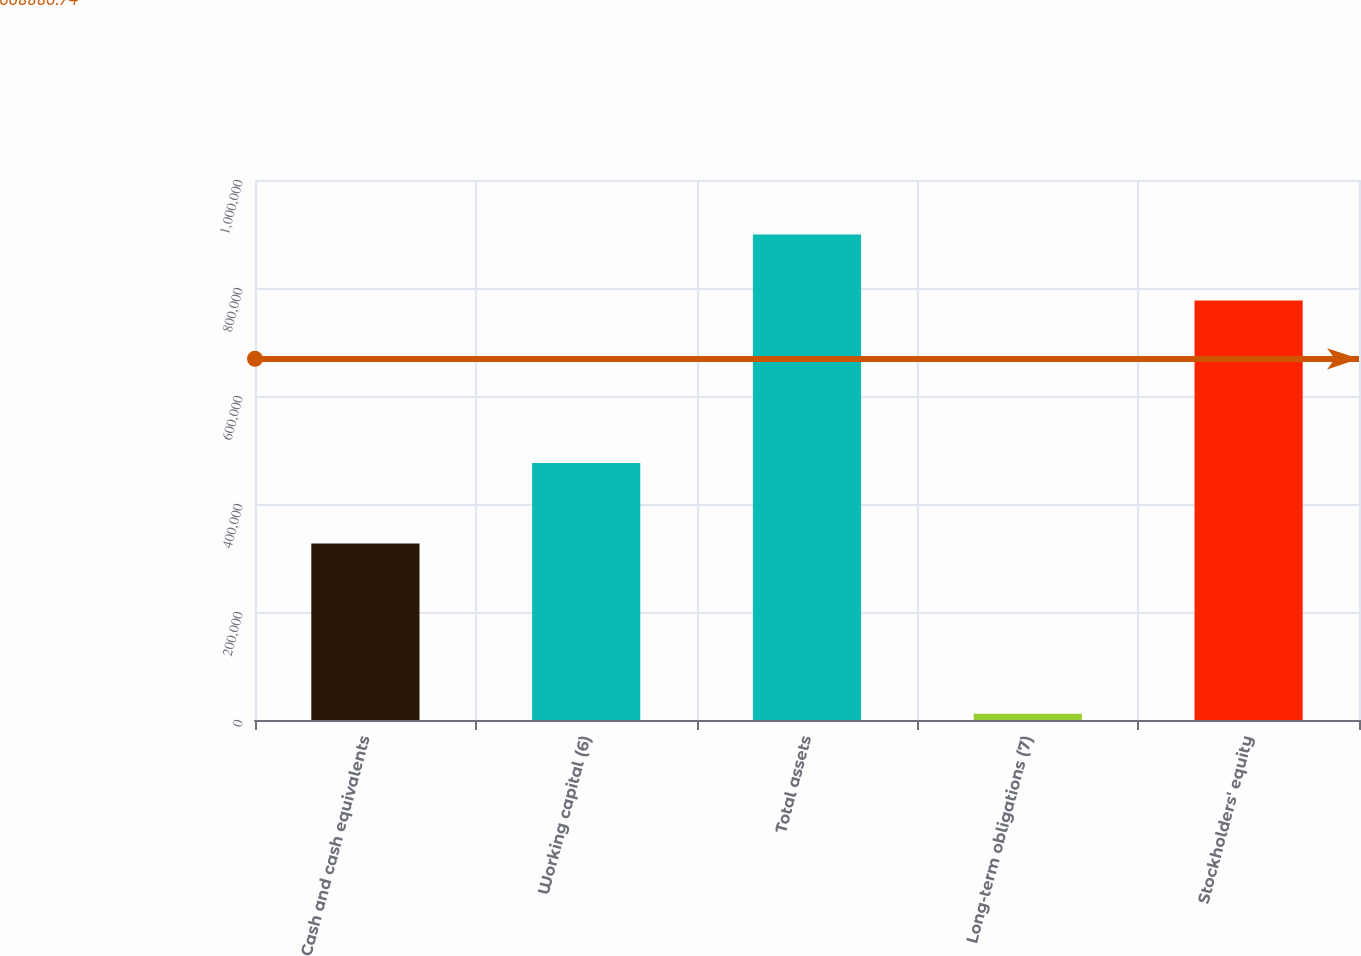Convert chart to OTSL. <chart><loc_0><loc_0><loc_500><loc_500><bar_chart><fcel>Cash and cash equivalents<fcel>Working capital (6)<fcel>Total assets<fcel>Long-term obligations (7)<fcel>Stockholders' equity<nl><fcel>326695<fcel>475899<fcel>899006<fcel>11515<fcel>776925<nl></chart> 